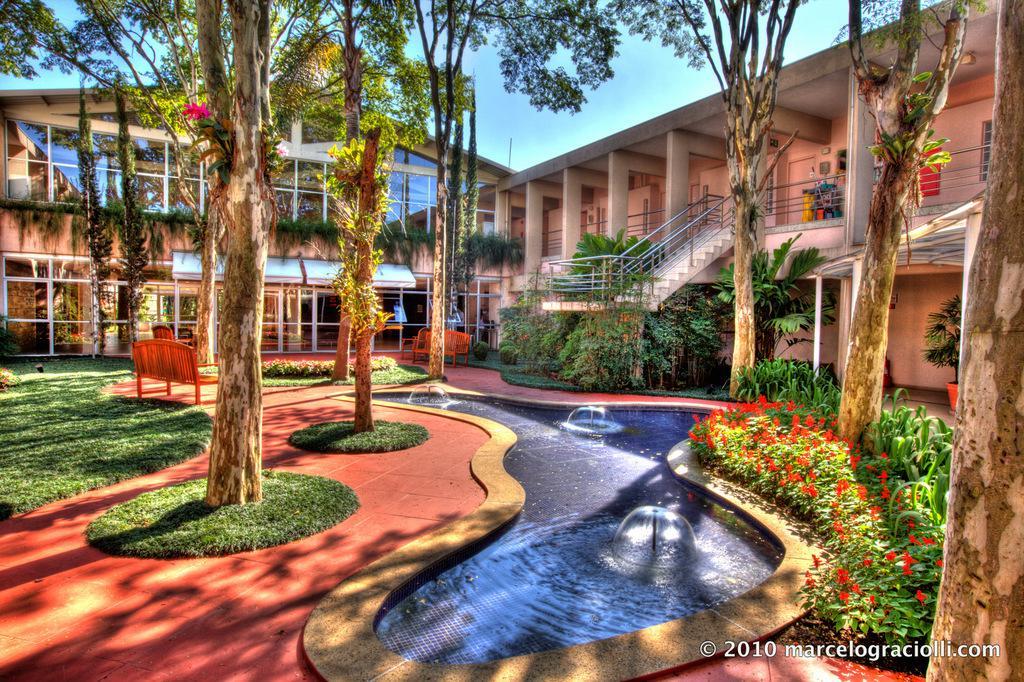Could you give a brief overview of what you see in this image? In this image I can see the ground, some grass, few trees, a swimming pool, few flowers which are red in color, a bench, few stairs, the railing and a building. In the background I can see the sky. 